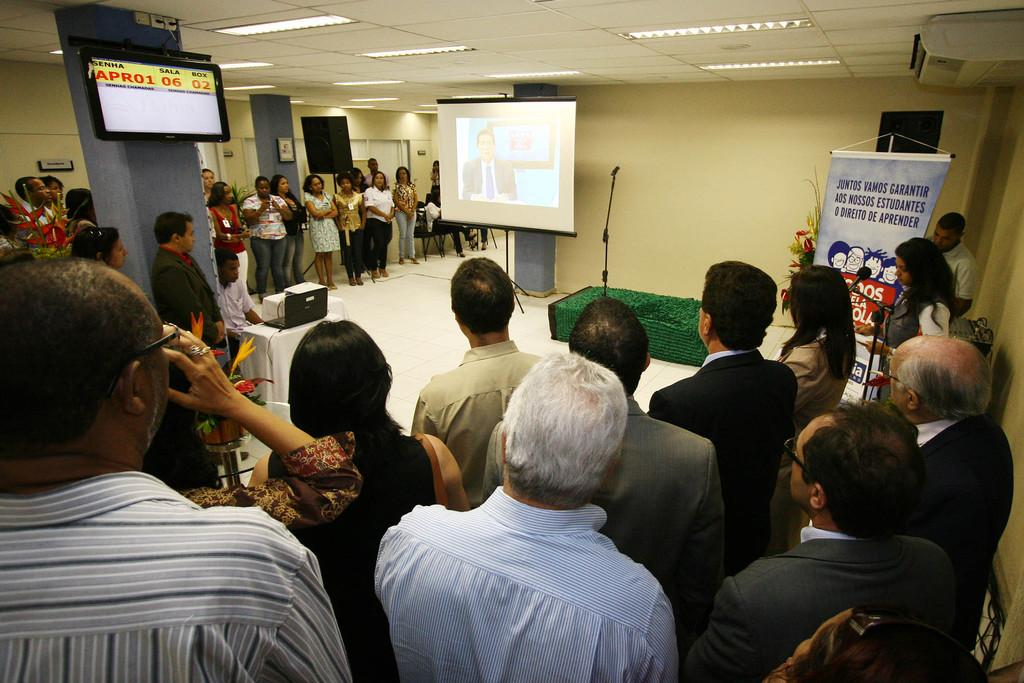What can be seen in the image? There are people standing in the image, and there is a projector screen in the middle of the image. Can you describe the people in the image? The facts provided do not give specific details about the people, so we cannot describe them further. What is the purpose of the projector screen in the image? The purpose of the projector screen is not specified in the facts, so we cannot determine its purpose from the information given. How many birds are sitting on the projector screen in the image? There are no birds present in the image; it only features people and a projector screen. What type of footwear are the people wearing in the image? The facts provided do not give specific details about the people's footwear, so we cannot describe it further. 